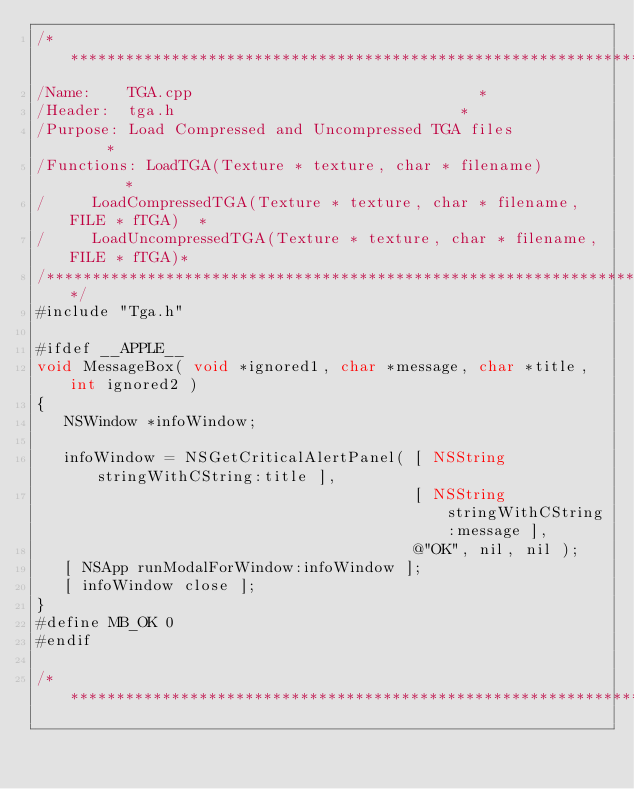Convert code to text. <code><loc_0><loc_0><loc_500><loc_500><_ObjectiveC_>/********************************************************************************
/Name:		TGA.cpp																*
/Header:	tga.h																*
/Purpose:	Load Compressed and Uncompressed TGA files							*
/Functions:	LoadTGA(Texture * texture, char * filename)							*
/			LoadCompressedTGA(Texture * texture, char * filename, FILE * fTGA)	*
/			LoadUncompressedTGA(Texture * texture, char * filename, FILE * fTGA)*	
/*******************************************************************************/
#include "Tga.h"

#ifdef __APPLE__
void MessageBox( void *ignored1, char *message, char *title, int ignored2 )
{ 
   NSWindow *infoWindow;
   
   infoWindow = NSGetCriticalAlertPanel( [ NSString stringWithCString:title ],
                                         [ NSString stringWithCString:message ],
                                         @"OK", nil, nil );
   [ NSApp runModalForWindow:infoWindow ];
   [ infoWindow close ];
}
#define MB_OK 0
#endif

/********************************************************************************</code> 